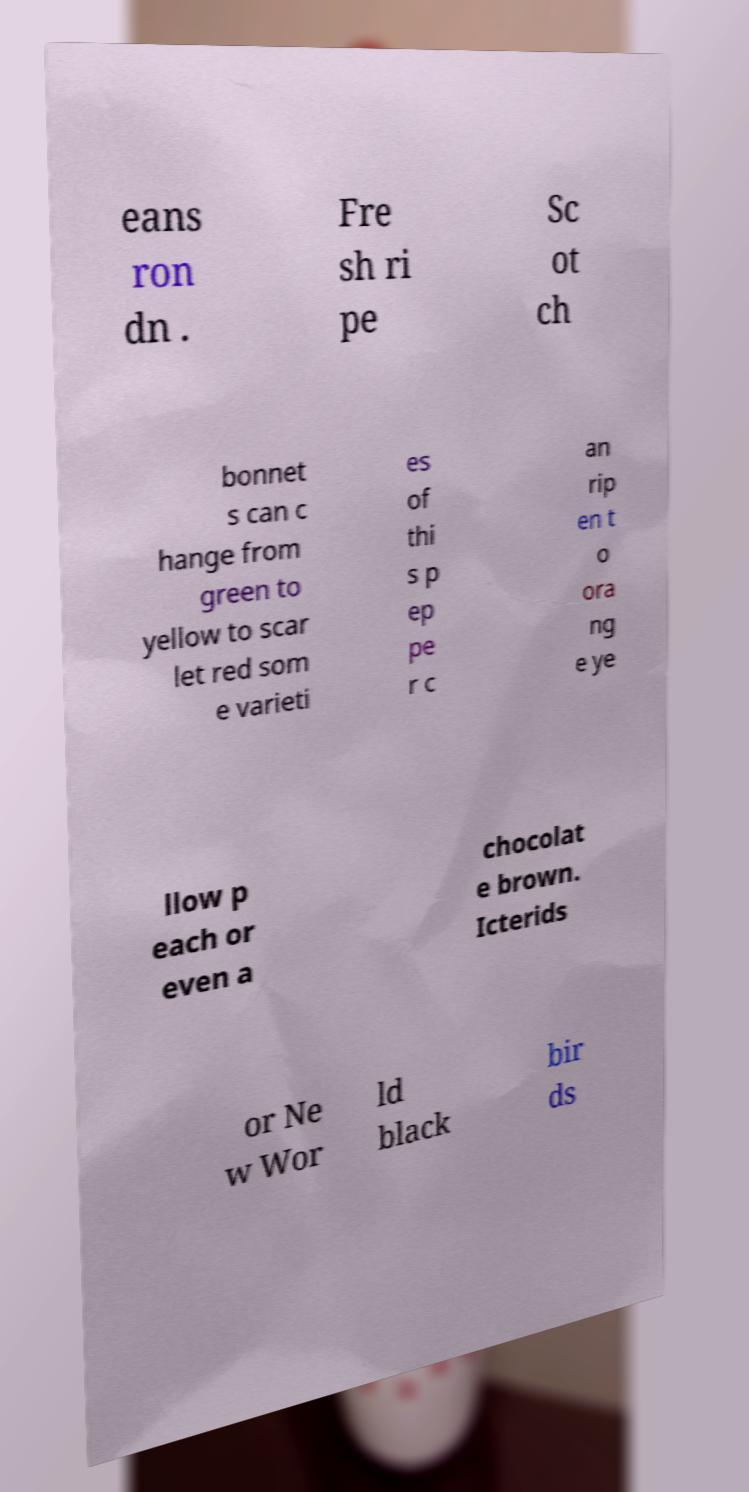I need the written content from this picture converted into text. Can you do that? eans ron dn . Fre sh ri pe Sc ot ch bonnet s can c hange from green to yellow to scar let red som e varieti es of thi s p ep pe r c an rip en t o ora ng e ye llow p each or even a chocolat e brown. Icterids or Ne w Wor ld black bir ds 